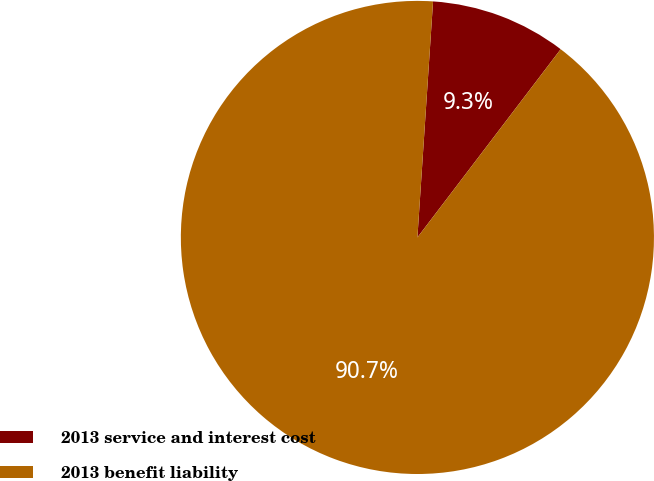Convert chart to OTSL. <chart><loc_0><loc_0><loc_500><loc_500><pie_chart><fcel>2013 service and interest cost<fcel>2013 benefit liability<nl><fcel>9.3%<fcel>90.7%<nl></chart> 